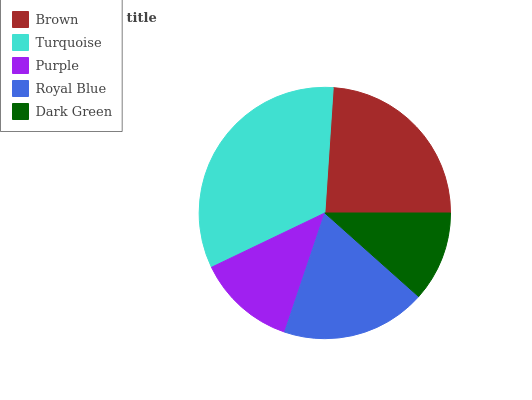Is Dark Green the minimum?
Answer yes or no. Yes. Is Turquoise the maximum?
Answer yes or no. Yes. Is Purple the minimum?
Answer yes or no. No. Is Purple the maximum?
Answer yes or no. No. Is Turquoise greater than Purple?
Answer yes or no. Yes. Is Purple less than Turquoise?
Answer yes or no. Yes. Is Purple greater than Turquoise?
Answer yes or no. No. Is Turquoise less than Purple?
Answer yes or no. No. Is Royal Blue the high median?
Answer yes or no. Yes. Is Royal Blue the low median?
Answer yes or no. Yes. Is Turquoise the high median?
Answer yes or no. No. Is Purple the low median?
Answer yes or no. No. 